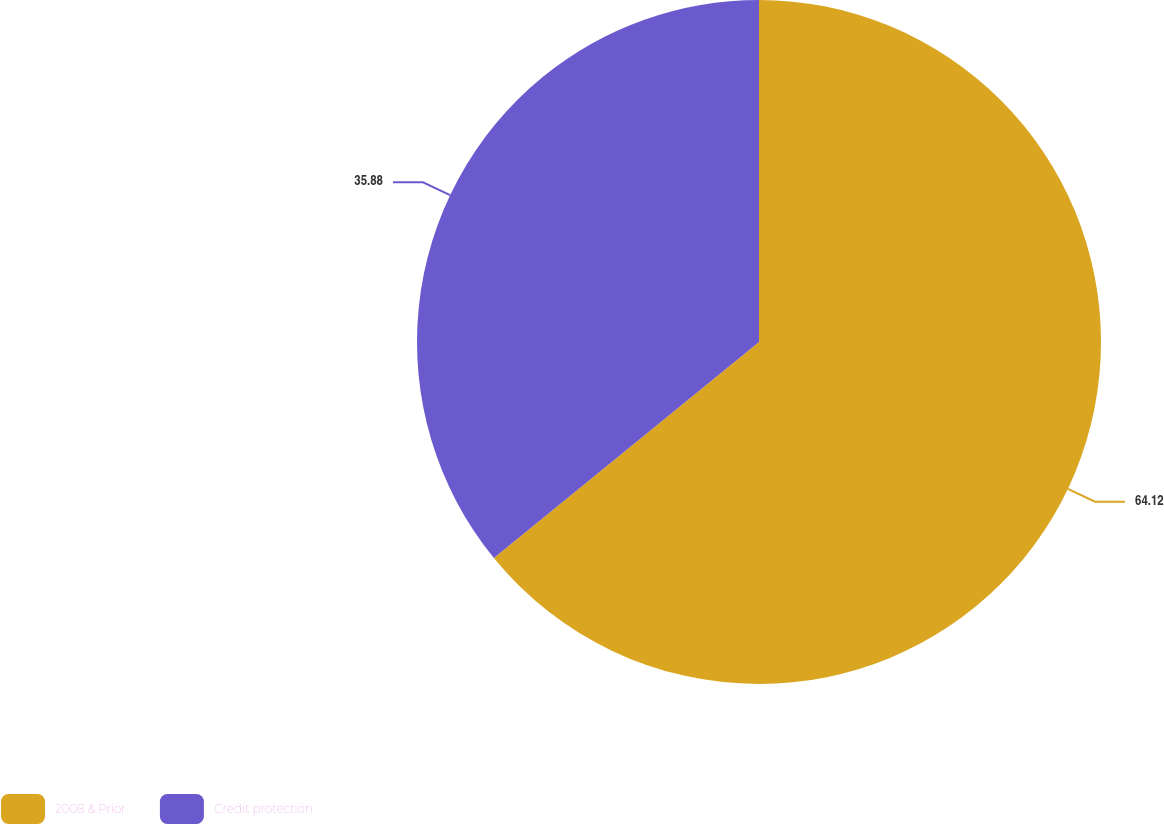<chart> <loc_0><loc_0><loc_500><loc_500><pie_chart><fcel>2008 & Prior<fcel>Credit protection<nl><fcel>64.12%<fcel>35.88%<nl></chart> 